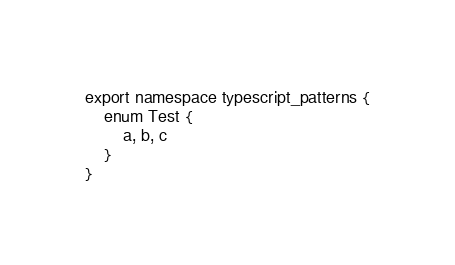<code> <loc_0><loc_0><loc_500><loc_500><_TypeScript_>export namespace typescript_patterns {
    enum Test {
        a, b, c
    }
}
</code> 